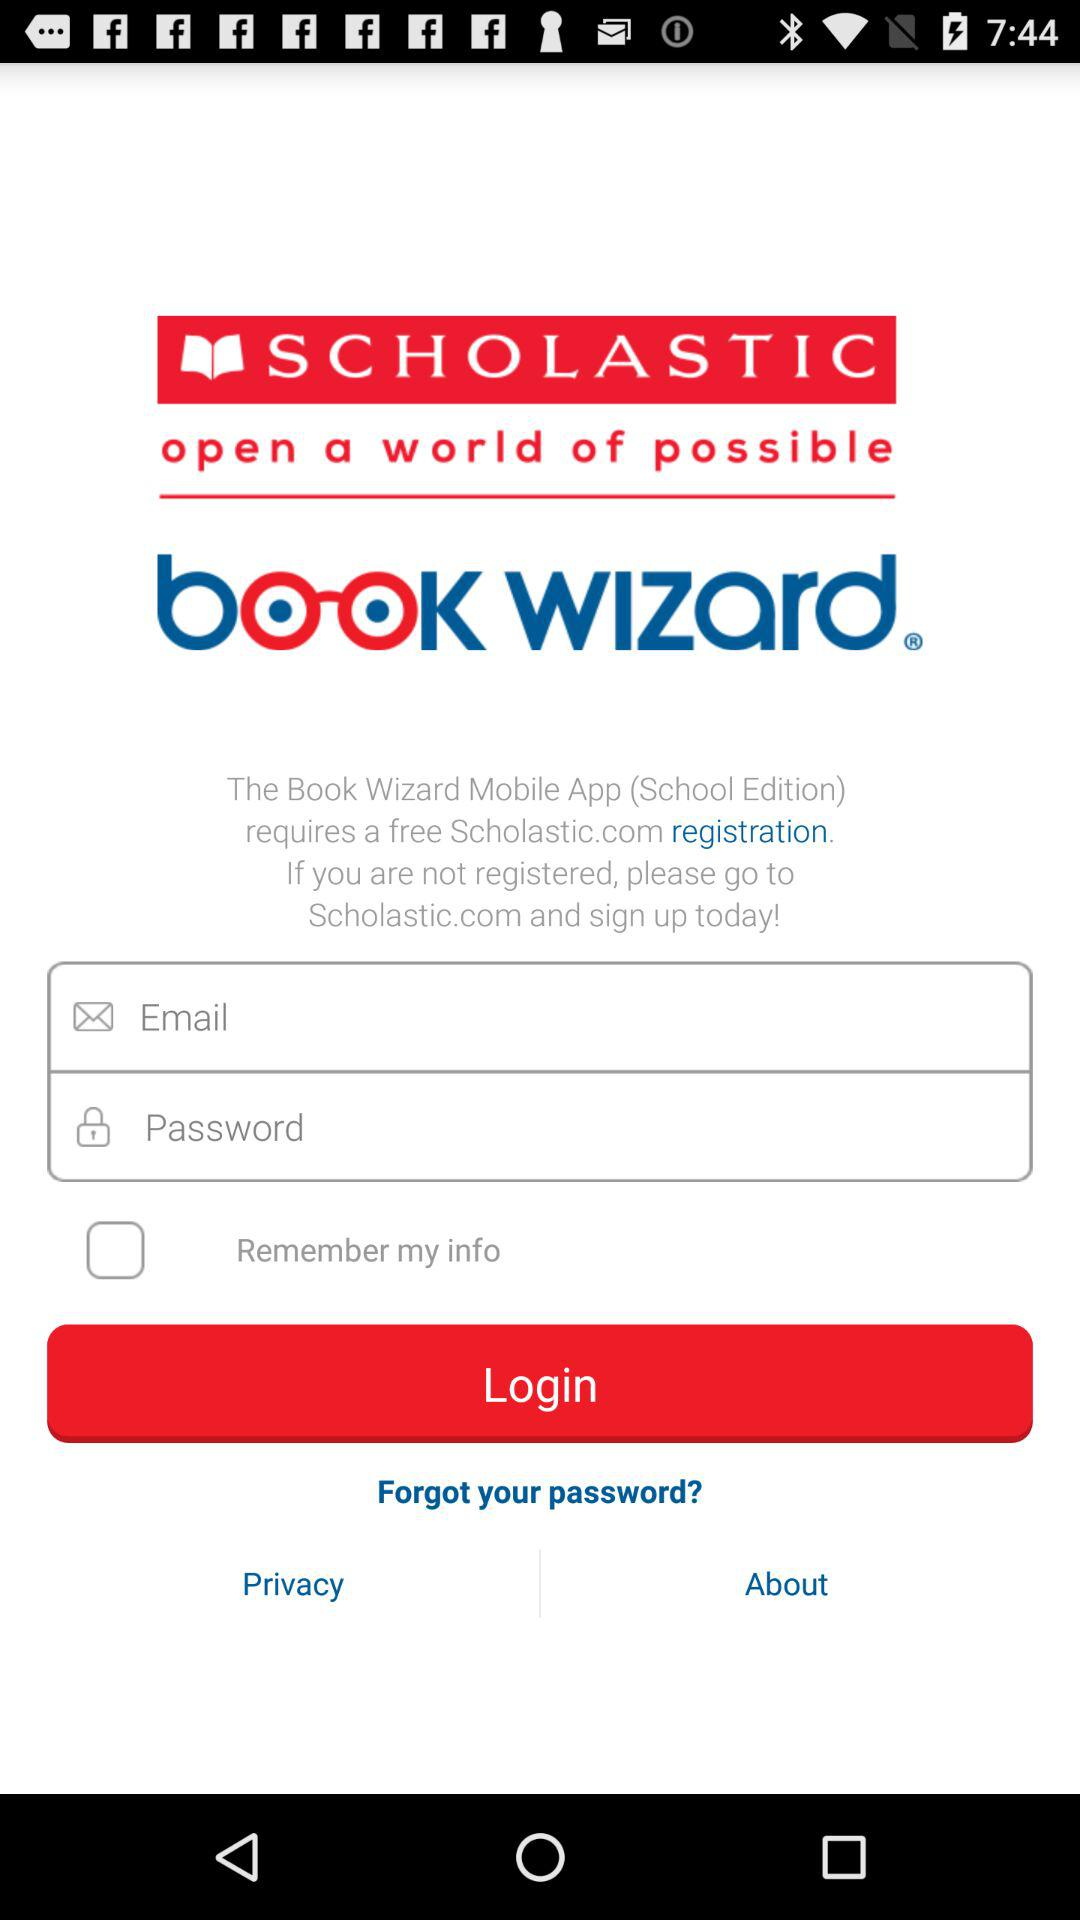What is the status of "Remember my info"? The status is "off". 